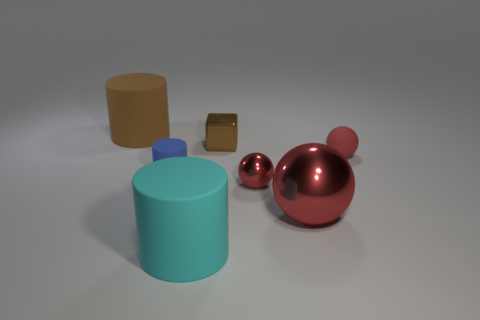Is there anything else that is the same size as the brown cylinder?
Your answer should be compact. Yes. What is the shape of the brown thing right of the big matte cylinder that is left of the large cylinder that is in front of the large brown matte cylinder?
Offer a terse response. Cube. There is a small thing that is both in front of the block and behind the blue thing; what shape is it?
Your response must be concise. Sphere. Is there a cylinder made of the same material as the big cyan thing?
Give a very brief answer. Yes. What size is the other shiny sphere that is the same color as the big ball?
Make the answer very short. Small. The big cylinder that is in front of the large red ball is what color?
Your response must be concise. Cyan. Is the shape of the brown matte thing the same as the tiny red thing that is in front of the small red matte thing?
Offer a very short reply. No. Is there a small rubber ball that has the same color as the small metallic block?
Make the answer very short. No. There is a brown cylinder that is made of the same material as the large cyan cylinder; what is its size?
Your response must be concise. Large. Is the color of the large sphere the same as the small metallic sphere?
Your answer should be compact. Yes. 